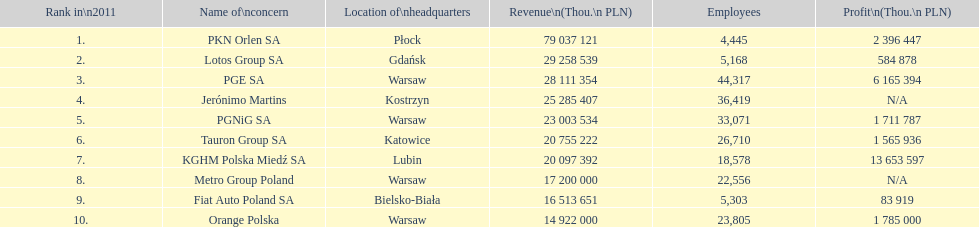How many companies had over $1,000,000 profit? 6. 